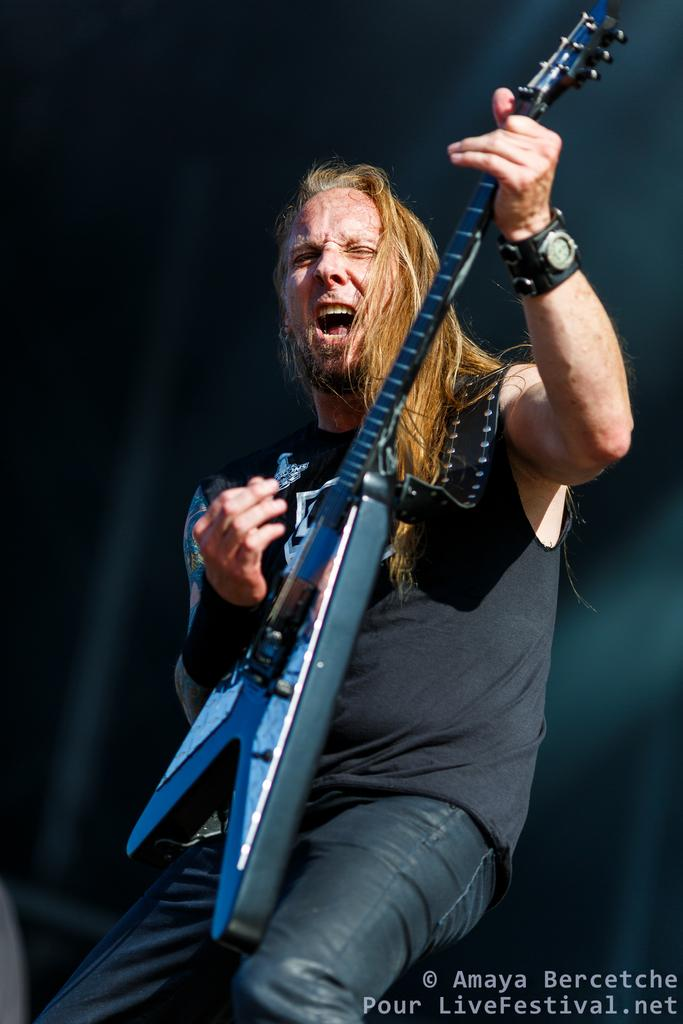What is the man in the image doing? The man is playing the guitar and singing. What type of clothing is the man wearing? The man is wearing a t-shirt and jeans. What color is the background of the image? The background of the image is black. What can be found in the bottom right corner of the image? There is text in the bottom right corner of the image. What type of cherry is the man holding in the image? There is no cherry present in the image. Where is the meeting taking place in the image? There is no meeting depicted in the image; it shows a man playing the guitar and singing. 